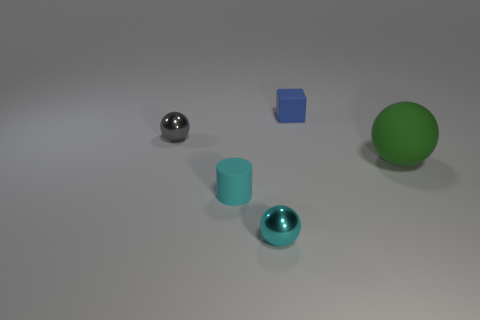There is a ball that is to the left of the small cyan thing to the right of the cyan rubber cylinder; what is it made of?
Provide a short and direct response. Metal. Is the number of rubber balls that are behind the green sphere the same as the number of cylinders that are to the right of the cyan metal thing?
Your answer should be compact. Yes. What number of objects are rubber things that are in front of the blue cube or shiny things that are on the right side of the rubber cylinder?
Give a very brief answer. 3. There is a thing that is both to the right of the tiny cyan ball and in front of the blue matte thing; what is its material?
Provide a succinct answer. Rubber. There is a matte object that is right of the small object right of the metallic object that is in front of the large rubber sphere; how big is it?
Offer a terse response. Large. Are there more big matte objects than gray cylinders?
Ensure brevity in your answer.  Yes. Is the material of the tiny sphere in front of the tiny gray sphere the same as the small gray sphere?
Make the answer very short. Yes. Is the number of tiny things less than the number of red cylinders?
Make the answer very short. No. Are there any cyan metal things on the right side of the shiny object that is in front of the sphere behind the green rubber ball?
Your answer should be compact. No. Is the shape of the matte thing right of the tiny blue rubber thing the same as  the small gray shiny object?
Give a very brief answer. Yes. 